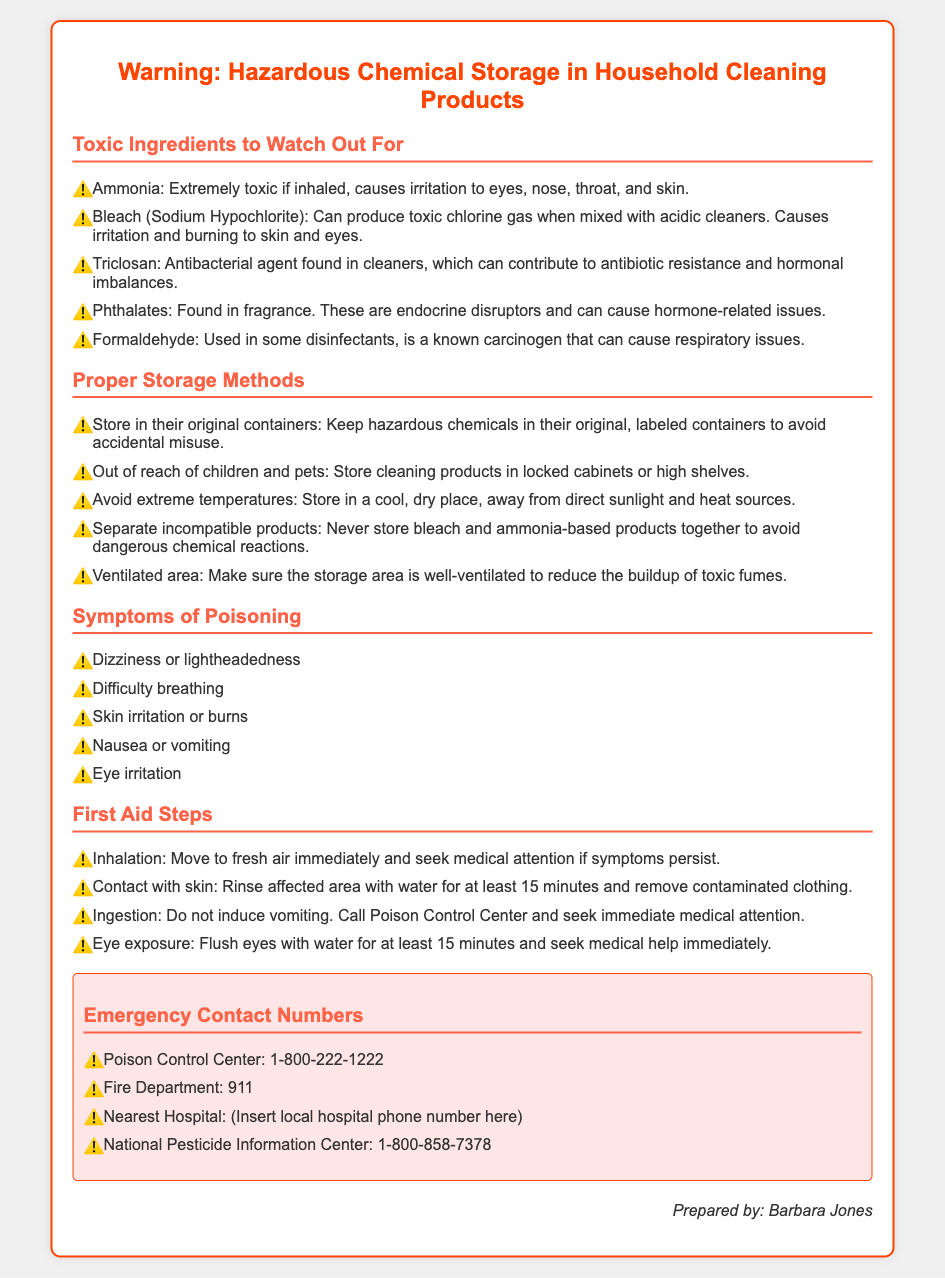What is the first toxic ingredient listed? The first toxic ingredient mentioned in the document is Ammonia.
Answer: Ammonia What should hazardous chemicals be stored in? The document states that hazardous chemicals should be stored in their original containers.
Answer: Original containers What is the emergency contact number for Poison Control Center? The document provides the Poison Control Center number as 1-800-222-1222.
Answer: 1-800-222-1222 What symptom is associated with dizziness? Dizziness is a symptom of poisoning listed in the document.
Answer: Dizziness Why should cleaning products be stored out of reach of children? Keeping cleaning products out of reach of children is to prevent accidental poisoning.
Answer: Prevent accidental poisoning What is one proper storage method mentioned? One proper storage method mentioned is to store in a cool, dry place.
Answer: Store in a cool, dry place What should you do if you have skin contact with a hazardous chemical? The document advises rinsing the affected area with water for at least 15 minutes.
Answer: Rinse affected area with water for at least 15 minutes What can occur if bleach is mixed with acidic cleaners? The document warns that mixing bleach with acidic cleaners can produce toxic chlorine gas.
Answer: Toxic chlorine gas What are phthalates known to disrupt? Phthalates are known as endocrine disruptors, causing hormone-related issues.
Answer: Endocrine disruptors 